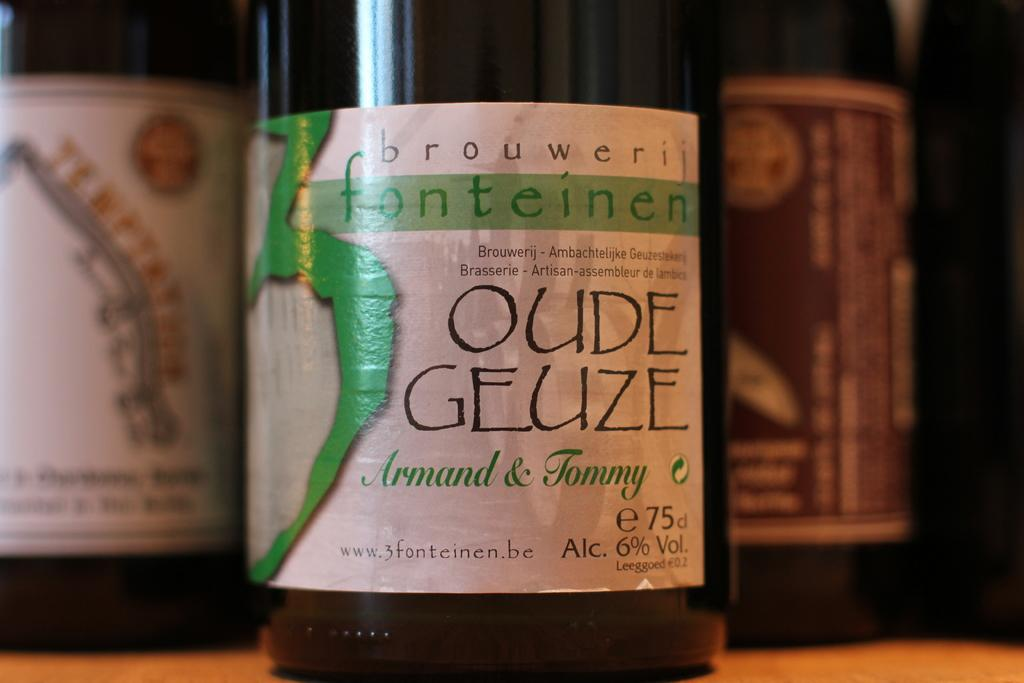<image>
Create a compact narrative representing the image presented. A bottle of Oude Geuze win has a URL on the label. 